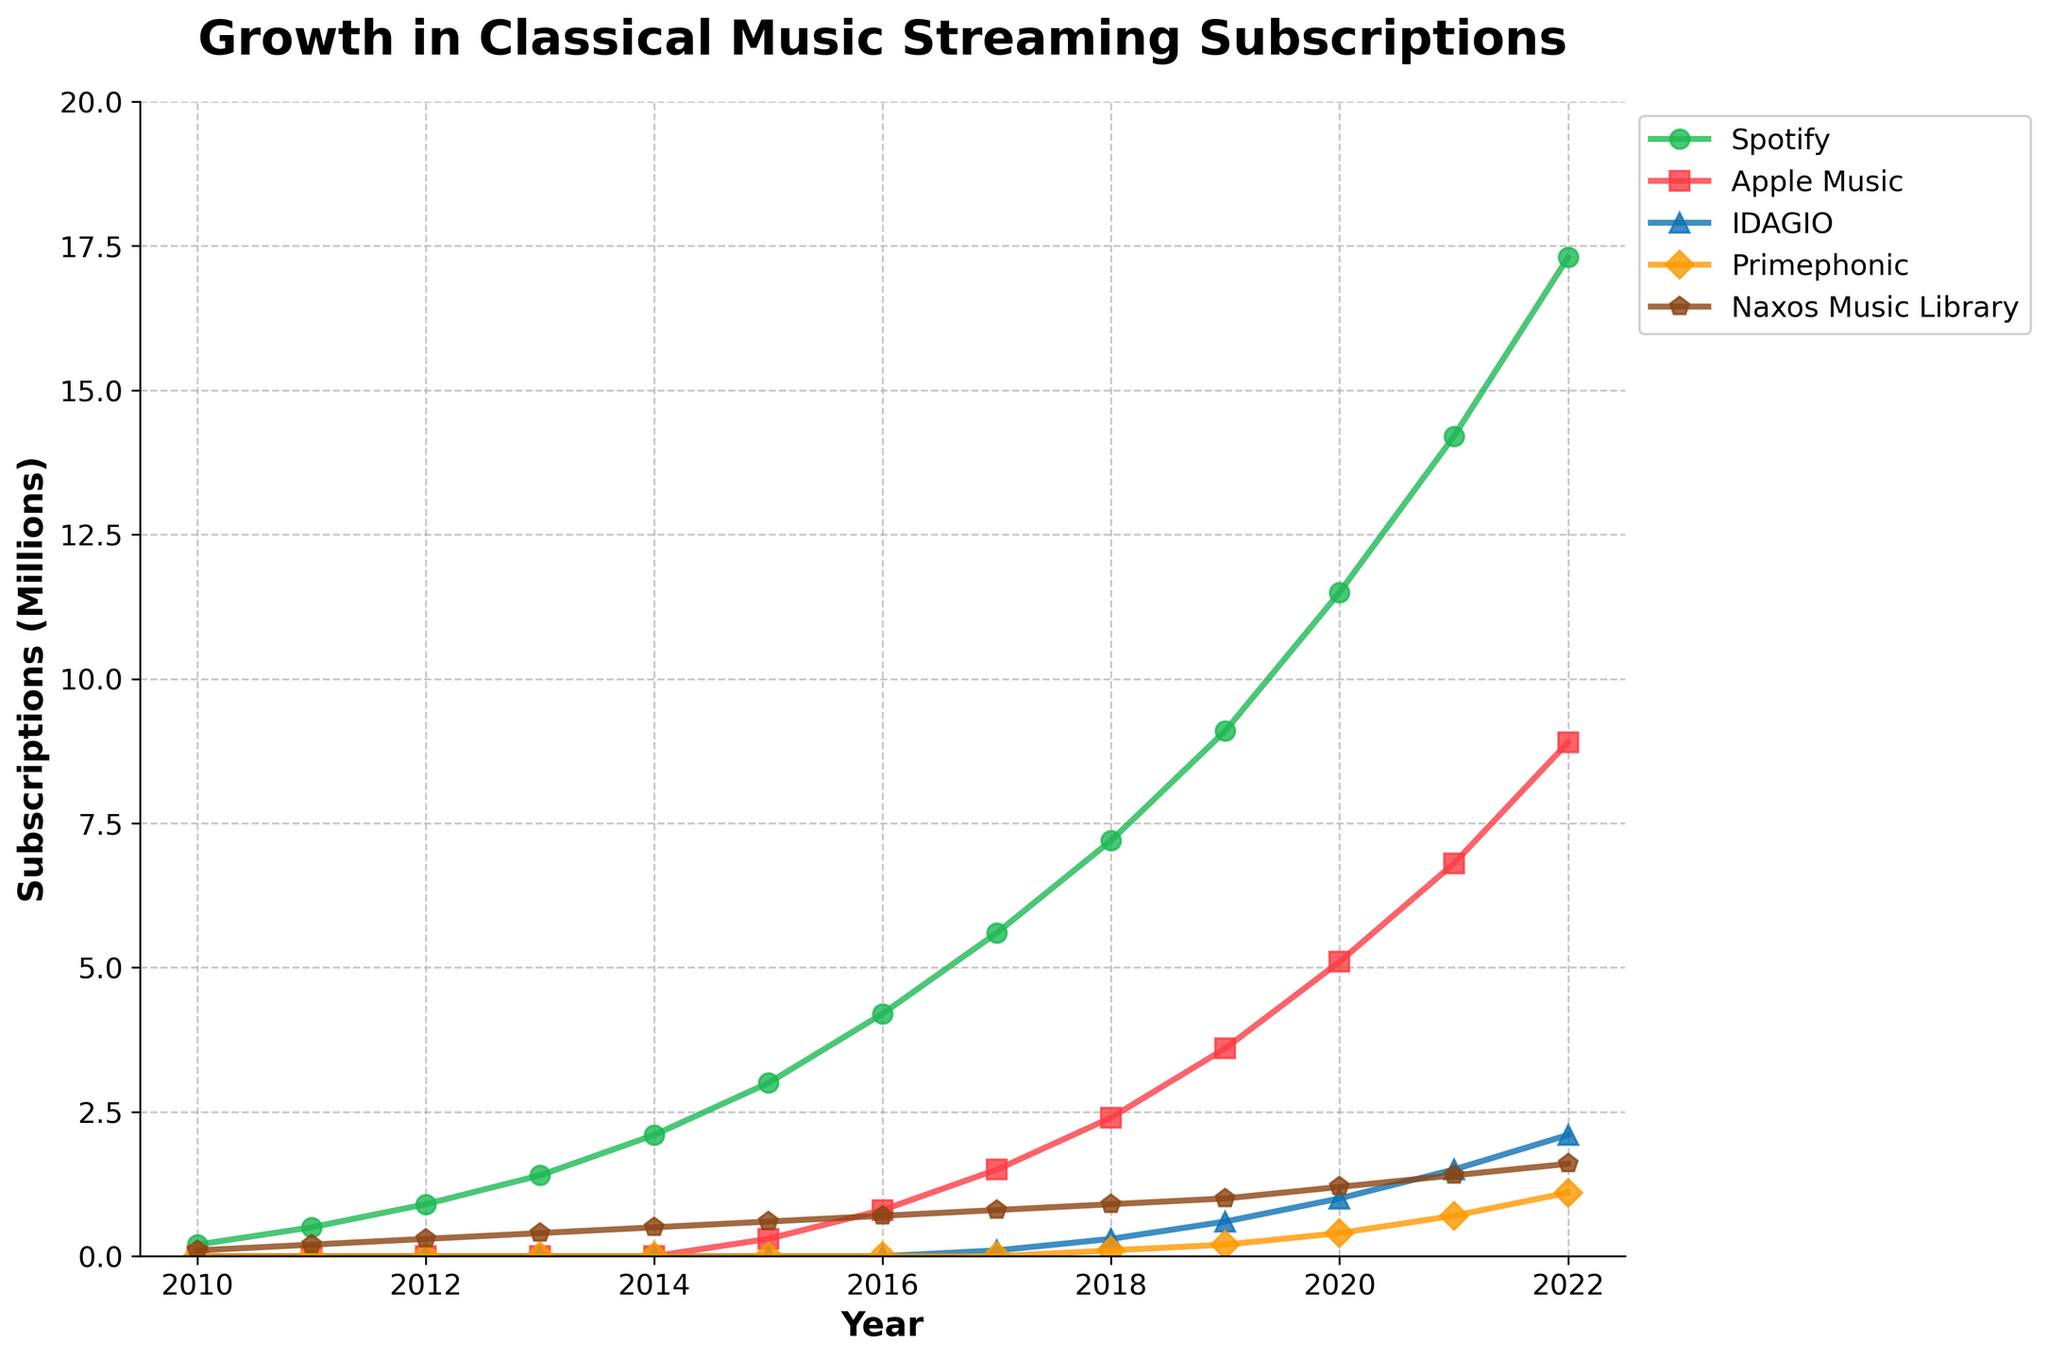Which platform showed the most significant growth in subscriptions from 2010 to 2022? By comparing the lines on the chart, Spotify displays the steepest upward trajectory, indicating the most significant growth in subscriptions.
Answer: Spotify Which year did Apple Music subscriptions first become noticeable on the chart? Observing the chart, Apple Music starts appearing around 2015.
Answer: 2015 How do the 2016 subscriptions for Spotify compare to those for Apple Music? In 2016, Spotify had about 4.2 million subscriptions, while Apple Music had roughly 0.8 million. Thus, Spotify had significantly more subscriptions than Apple Music in that year.
Answer: Spotify had more subscriptions What is the difference in the number of subscriptions between Spotify and IDAGIO in 2021? In 2021, Spotify had about 14.2 million subscriptions, and IDAGIO had roughly 1.5 million. The difference is 14.2 - 1.5 = 12.7 million.
Answer: 12.7 million Which platform shows the slowest growth and remains the smallest in 2022? Observing the chart, Primephonic shows the slowest growth and has the smallest number of subscriptions in 2022 with approximately 1.1 million.
Answer: Primephonic Did Naxos Music Library ever surpass Apple Music in subscriptions from 2010 to 2022? Throughout the entire period, Apple Music surpasses Naxos Music Library from 2015 onwards, as shown by the higher values of subscriptions for Apple Music compared to Naxos Music Library.
Answer: No Which year did Spotify surpass the 10 million subscriptions mark? By referencing the chart, it can be seen that Spotify exceeded 10 million subscriptions in 2020.
Answer: 2020 From 2019 to 2020, which platform had the highest increase in subscriptions? The increase for each platform from 2019 to 2020 can be calculated. For Spotify: 11.5 - 9.1 = 2.4 million. For Apple Music: 5.1 - 3.6 = 1.5 million. For IDAGIO: 1.0 - 0.6 = 0.4 million. For Primephonic: 0.4 - 0.2 = 0.2 million. For Naxos Music Library: 1.2 - 1.0 = 0.2 million. The highest increase is seen in Spotify with 2.4 million subscriptions.
Answer: Spotify If you sum the subscriptions of IDAGIO, Primephonic, and Naxos Music Library for 2021, what is the total? Adding the 2021 subscriptions of IDAGIO (1.5 million), Primephonic (0.7 million), and Naxos Music Library (1.4 million) gives a total of 1.5 + 0.7 + 1.4 = 3.6 million.
Answer: 3.6 million Which platform had a more rapid initial growth between 2015 and 2018, Spotify or Apple Music? In 2015, Spotify's subscriptions increased from 3.0 million to 7.2 million in 2018, a difference of 7.2 - 3.0 = 4.2 million. For Apple Music, subscriptions grew from 0.3 million in 2015 to 2.4 million in 2018, a difference of 2.4 - 0.3 = 2.1 million. Thus, Spotify had a more rapid initial growth.
Answer: Spotify 